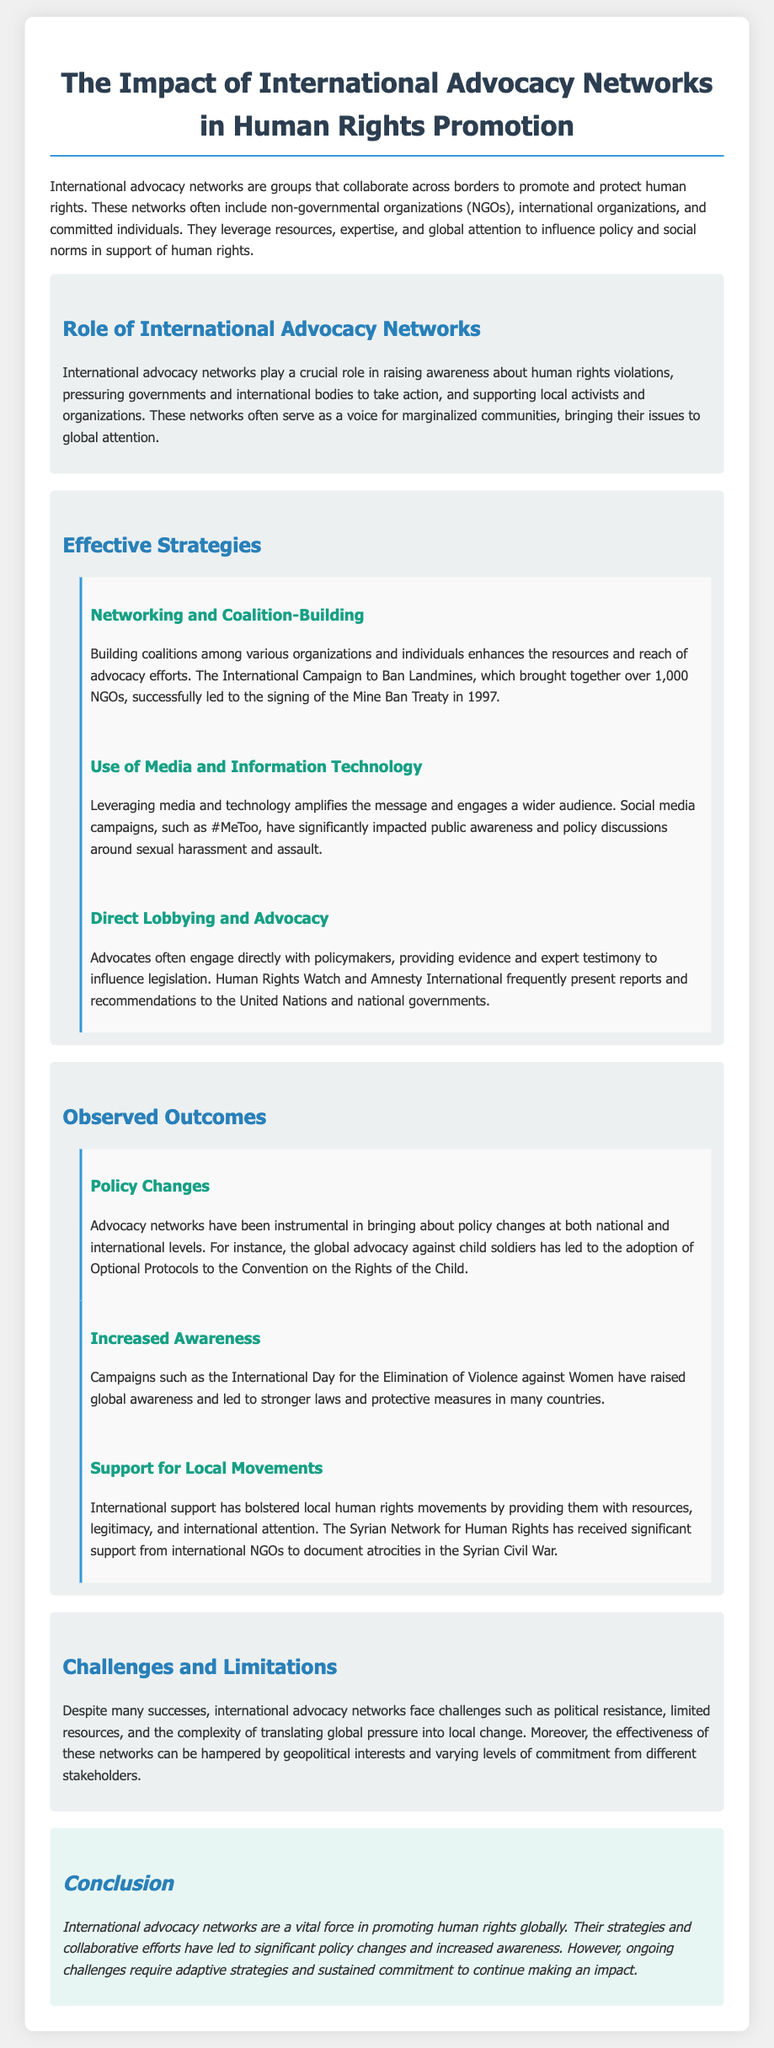What is the main focus of international advocacy networks? The document states that the main focus of international advocacy networks is to collaborate across borders to promote and protect human rights.
Answer: human rights What was the successful outcome of the International Campaign to Ban Landmines? The document mentions that the campaign led to the signing of the Mine Ban Treaty in 1997.
Answer: Mine Ban Treaty Which campaign significantly impacted public awareness of sexual harassment? The document highlights the #MeToo campaign as having a significant impact on public awareness and policy discussions around sexual harassment and assault.
Answer: #MeToo What is one observed outcome of advocacy networks in relation to policy? The document states that advocacy networks have been instrumental in bringing about policy changes at national and international levels.
Answer: policy changes What organization frequently presents reports to the United Nations? The document indicates that Human Rights Watch frequently presents reports and recommendations to the United Nations and national governments.
Answer: Human Rights Watch Which network has supported local human rights movements in Syria? The Syrian Network for Human Rights has received significant support from international NGOs to document atrocities in the Syrian Civil War.
Answer: Syrian Network for Human Rights What is a significant challenge faced by international advocacy networks? The document notes that political resistance is a challenge faced by international advocacy networks.
Answer: political resistance What is the role of international advocacy networks in relation to marginalized communities? According to the document, these networks serve as a voice for marginalized communities, bringing their issues to global attention.
Answer: voice for marginalized communities 